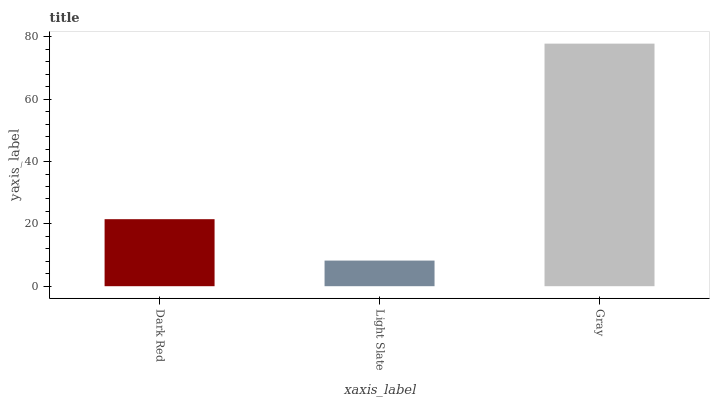Is Light Slate the minimum?
Answer yes or no. Yes. Is Gray the maximum?
Answer yes or no. Yes. Is Gray the minimum?
Answer yes or no. No. Is Light Slate the maximum?
Answer yes or no. No. Is Gray greater than Light Slate?
Answer yes or no. Yes. Is Light Slate less than Gray?
Answer yes or no. Yes. Is Light Slate greater than Gray?
Answer yes or no. No. Is Gray less than Light Slate?
Answer yes or no. No. Is Dark Red the high median?
Answer yes or no. Yes. Is Dark Red the low median?
Answer yes or no. Yes. Is Gray the high median?
Answer yes or no. No. Is Light Slate the low median?
Answer yes or no. No. 